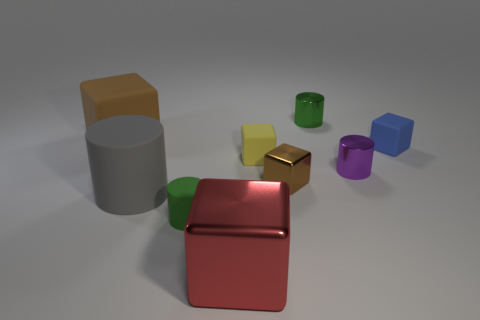How many brown cubes must be subtracted to get 1 brown cubes? 1 Subtract 1 blocks. How many blocks are left? 4 Subtract all tiny yellow matte blocks. How many blocks are left? 4 Subtract all yellow blocks. How many blocks are left? 4 Subtract all cyan cylinders. Subtract all red cubes. How many cylinders are left? 4 Add 1 tiny shiny cylinders. How many objects exist? 10 Subtract all cylinders. How many objects are left? 5 Subtract 0 green spheres. How many objects are left? 9 Subtract all gray rubber objects. Subtract all big red blocks. How many objects are left? 7 Add 6 big red objects. How many big red objects are left? 7 